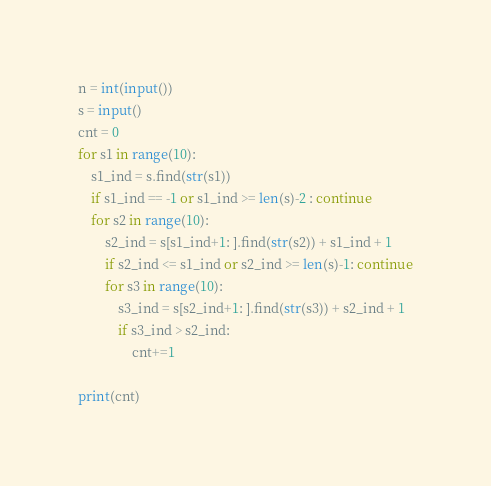Convert code to text. <code><loc_0><loc_0><loc_500><loc_500><_Python_>n = int(input())
s = input()
cnt = 0
for s1 in range(10):
    s1_ind = s.find(str(s1))
    if s1_ind == -1 or s1_ind >= len(s)-2 : continue
    for s2 in range(10):
        s2_ind = s[s1_ind+1: ].find(str(s2)) + s1_ind + 1
        if s2_ind <= s1_ind or s2_ind >= len(s)-1: continue
        for s3 in range(10):
            s3_ind = s[s2_ind+1: ].find(str(s3)) + s2_ind + 1
            if s3_ind > s2_ind: 
                cnt+=1

print(cnt)

</code> 